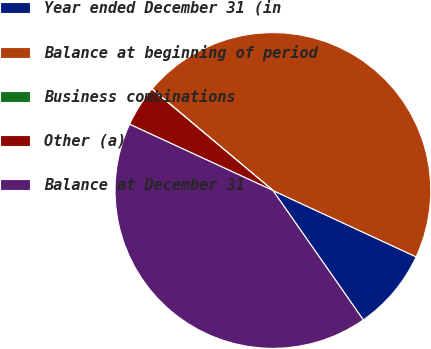Convert chart to OTSL. <chart><loc_0><loc_0><loc_500><loc_500><pie_chart><fcel>Year ended December 31 (in<fcel>Balance at beginning of period<fcel>Business combinations<fcel>Other (a)<fcel>Balance at December 31<nl><fcel>8.39%<fcel>45.78%<fcel>0.02%<fcel>4.21%<fcel>41.59%<nl></chart> 